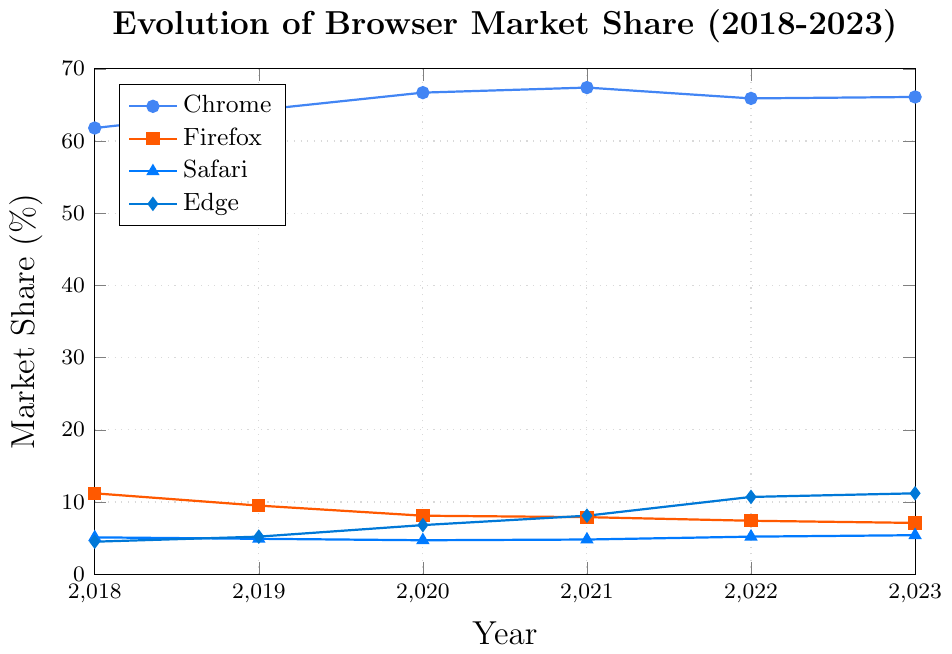Which browser had the highest market share in 2023? The highest mark (66.1) in 2023 is for Chrome, indicating it has the highest market share.
Answer: Chrome What is the percentage increase in Edge’s market share from 2018 to 2023? The market share of Edge in 2018 is 4.5% and in 2023 is 11.2%. The difference (11.2 - 4.5) is 6.7%. The percentage increase is (6.7 / 4.5) * 100 = 148.89%
Answer: 148.89% Which browser experienced the most consistent decline in market share over the observed period? Looking at the trend lines, Firefox shows a consistent decline from 11.2% in 2018 to 7.1% in 2023.
Answer: Firefox For which years did Edge have a higher market share than Safari? Comparing the points visually, Edge had a higher market share than Safari in the years 2020, 2021, 2022, and 2023.
Answer: 2020, 2021, 2022, 2023 How did Chrome's market share in 2020 compare to its market share in 2023? In 2020, Chrome had a market share of 66.7%, and in 2023 it was 66.1%. This shows a slight decline by 0.6%.
Answer: Declined by 0.6% Which two-year span saw the greatest increase in market share for Edge? Edge’s market share goes from 4.5% in 2018 to 5.2% in 2019 (change of 0.7), 5.2% in 2019 to 6.8% in 2020 (change of 1.6), 6.8% in 2020 to 8.1% in 2021 (change of 1.3), 8.1% in 2021 to 10.7% in 2022 (change of 2.6), and 10.7% in 2022 to 11.2% in 2023 (change of 0.5). The greatest increase is between 2021 and 2022 with a change of 2.6.
Answer: 2021 to 2022 In which year did Safari's market share show an increase compared to the previous year? The years to compare are from 2018 to 2023 for Safari. Safari's market share increased from 2021 (4.8%) to 2022 (5.2%), and from 2022 (5.2%) to 2023 (5.4%).
Answer: 2022, 2023 What is the average market share of Chrome over the 5 years? The market shares are 61.8%, 64.3%, 66.7%, 67.4%, 65.9%, and 66.1%. The sum is 392.2, and there are 6 years, so the average is 392.2 / 6 = 65.37%.
Answer: 65.37% What color represents Firefox in the plot? By the legend in the plot, Firefox is represented by an orange line.
Answer: Orange 